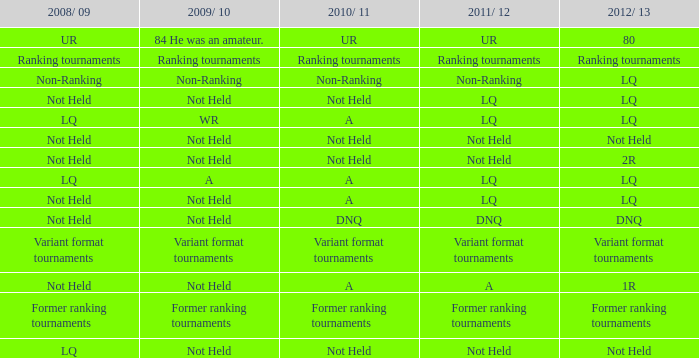If 2011/12 has no ranking, what does 2009/10 have? Non-Ranking. 